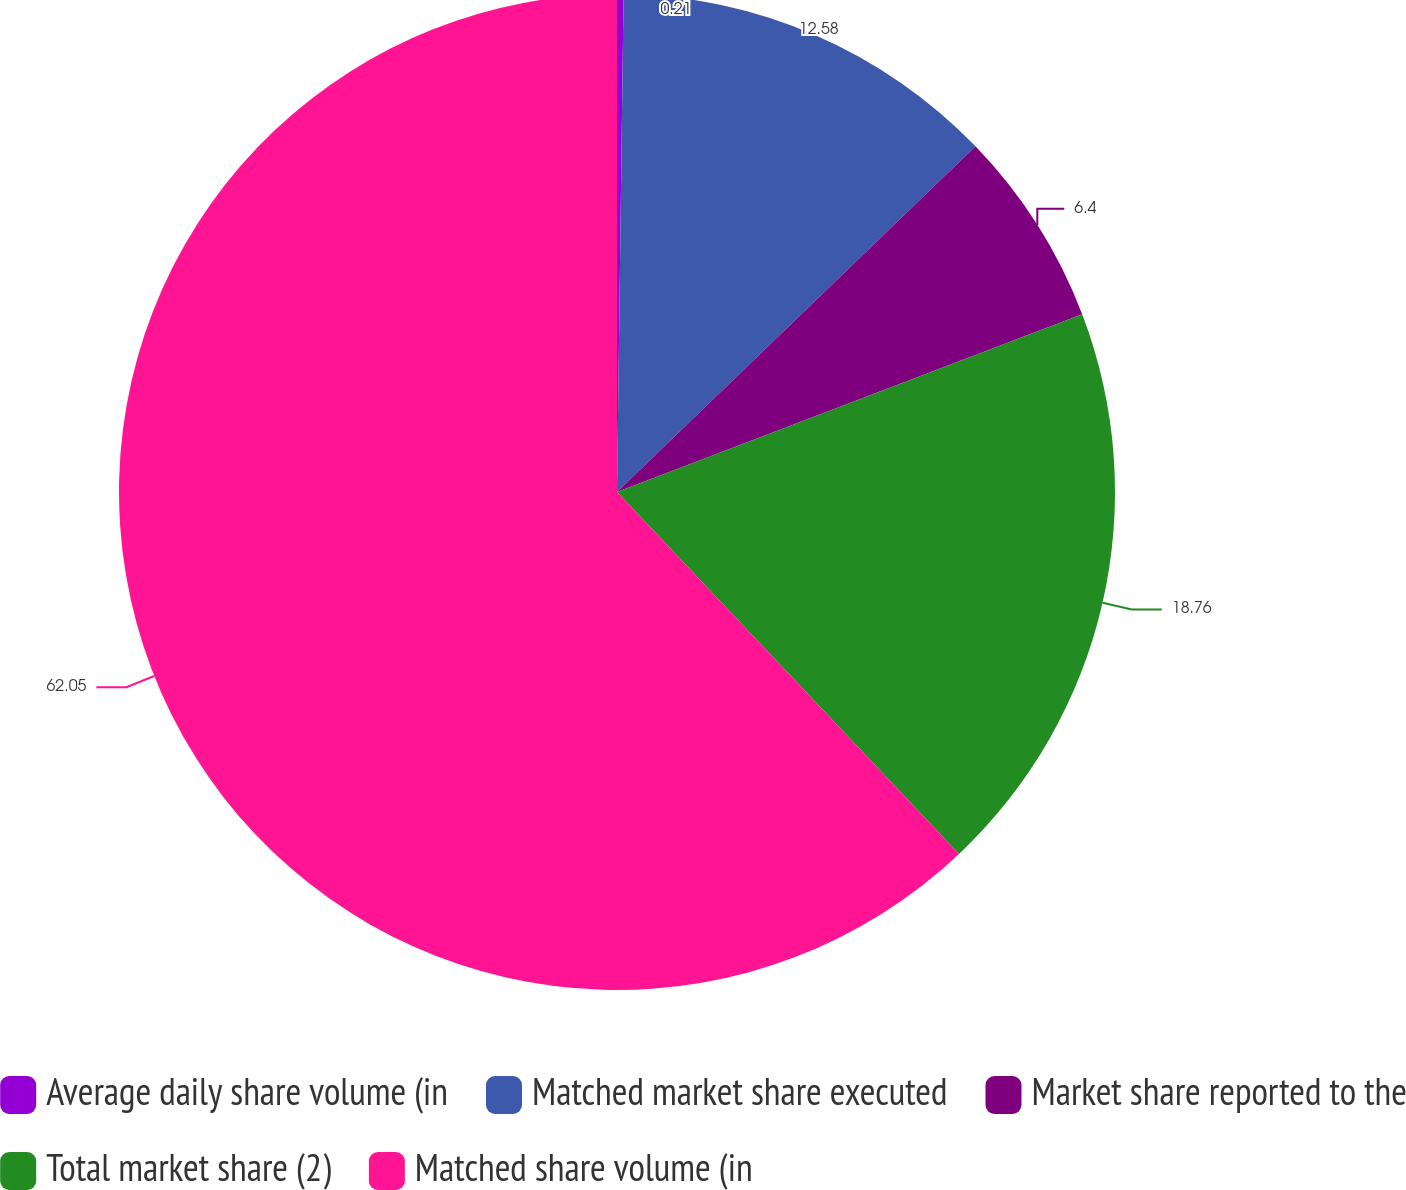<chart> <loc_0><loc_0><loc_500><loc_500><pie_chart><fcel>Average daily share volume (in<fcel>Matched market share executed<fcel>Market share reported to the<fcel>Total market share (2)<fcel>Matched share volume (in<nl><fcel>0.21%<fcel>12.58%<fcel>6.4%<fcel>18.76%<fcel>62.05%<nl></chart> 